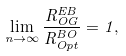<formula> <loc_0><loc_0><loc_500><loc_500>\lim _ { n \rightarrow \infty } \frac { R ^ { E B } _ { O G } } { R _ { O p t } ^ { B O } } = 1 ,</formula> 